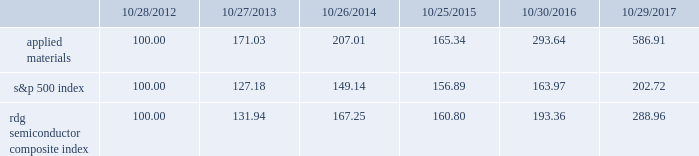Performance graph the performance graph below shows the five-year cumulative total stockholder return on applied common stock during the period from october 28 , 2012 through october 29 , 2017 .
This is compared with the cumulative total return of the standard & poor 2019s 500 stock index and the rdg semiconductor composite index over the same period .
The comparison assumes $ 100 was invested on october 28 , 2012 in applied common stock and in each of the foregoing indices and assumes reinvestment of dividends , if any .
Dollar amounts in the graph are rounded to the nearest whole dollar .
The performance shown in the graph represents past performance and should not be considered an indication of future performance .
Comparison of 5 year cumulative total return* among applied materials , inc. , the s&p 500 index and the rdg semiconductor composite index *assumes $ 100 invested on 10/28/12 in stock or 10/31/12 in index , including reinvestment of dividends .
Indexes calculated on month-end basis .
Copyright a9 2017 standard & poor 2019s , a division of s&p global .
All rights reserved. .
Dividends during each of fiscal 2017 , 2016 and 2015 , applied 2019s board of directors declared four quarterly cash dividends in the amount of $ 0.10 per share .
Applied currently anticipates that cash dividends will continue to be paid on a quarterly basis , although the declaration of any future cash dividend is at the discretion of the board of directors and will depend on applied 2019s financial condition , results of operations , capital requirements , business conditions and other factors , as well as a determination by the board of directors that cash dividends are in the best interests of applied 2019s stockholders .
10/28/12 10/27/13 10/26/14 10/25/15 10/30/16 10/29/17 applied materials , inc .
S&p 500 rdg semiconductor composite .
How much percent did the investor make on applied materials from the first 5 years compared to the 2016 to 2017 time period ? ( not including compound interest )? 
Rationale: to see the difference between the years one will need to calculate the total percentage change over those years . for the first 5 years its pretty easy because we started with $ 100 making it a 193% return . for the years 2016 to 2017 , one needs to subtract the starting price by the ending price and then divide that number by the starting price . this gives us a 99.9% return in 2016 to 2017 .
Computations: ((293.64 - 100) - ((586.91 - 293.64) / 293.64))
Answer: 192.64126. 